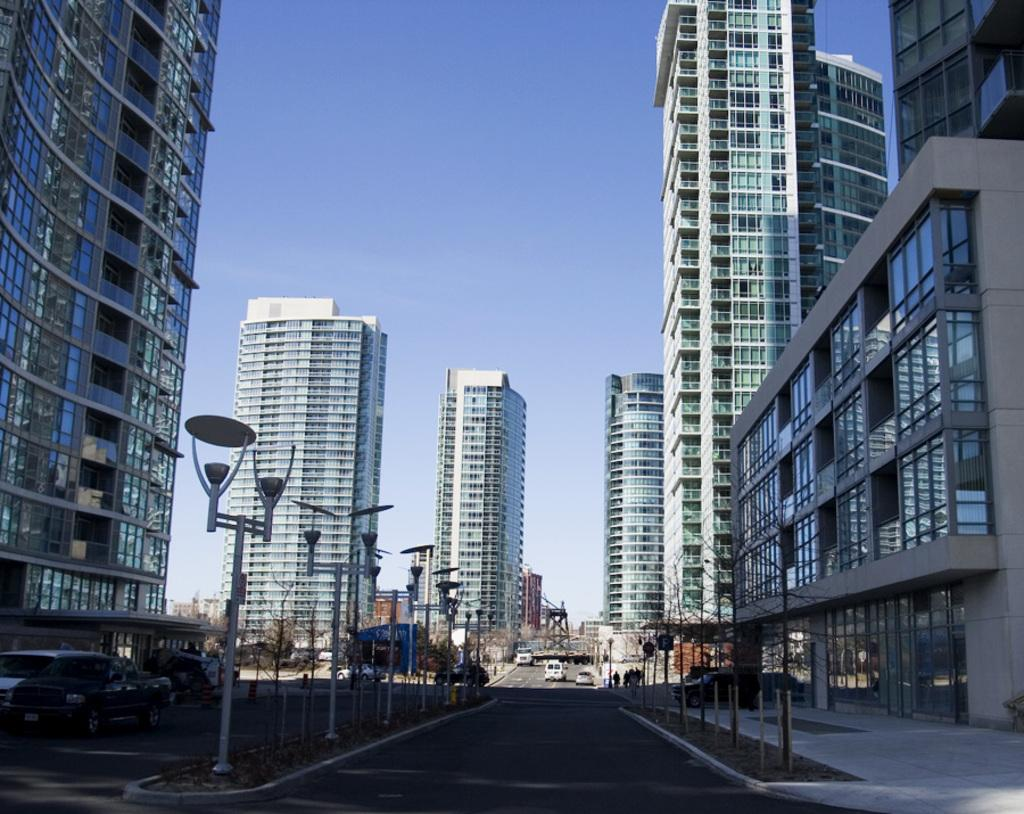What structures are located in the middle of the image? There are buildings in the middle of the image. What is visible at the top of the image? The sky is visible at the top of the image. What can be seen at the bottom of the image? There are vehicles at the bottom of the image. What type of cake is being served in the image? There is no cake present in the image. What is your opinion on the buildings in the image? The question asks for an opinion, which is not based on the facts provided. The conversation should focus on definitive answers based on the image. 